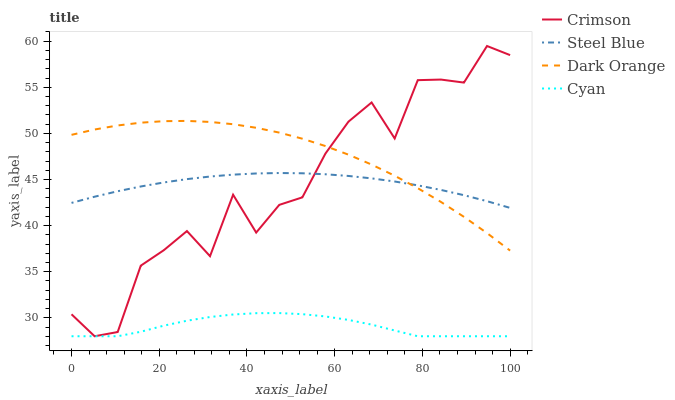Does Steel Blue have the minimum area under the curve?
Answer yes or no. No. Does Steel Blue have the maximum area under the curve?
Answer yes or no. No. Is Dark Orange the smoothest?
Answer yes or no. No. Is Dark Orange the roughest?
Answer yes or no. No. Does Dark Orange have the lowest value?
Answer yes or no. No. Does Dark Orange have the highest value?
Answer yes or no. No. Is Cyan less than Dark Orange?
Answer yes or no. Yes. Is Dark Orange greater than Cyan?
Answer yes or no. Yes. Does Cyan intersect Dark Orange?
Answer yes or no. No. 